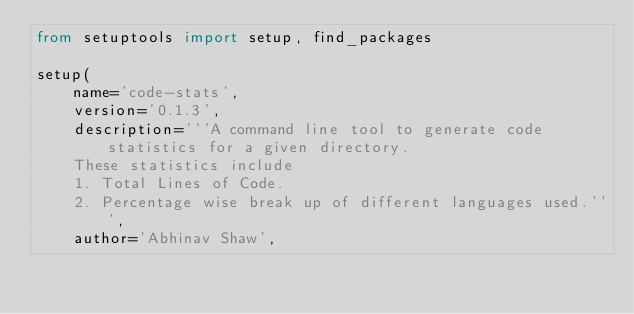Convert code to text. <code><loc_0><loc_0><loc_500><loc_500><_Python_>from setuptools import setup, find_packages

setup(
    name='code-stats',
    version='0.1.3',
    description='''A command line tool to generate code statistics for a given directory.
    These statistics include
    1. Total Lines of Code.
    2. Percentage wise break up of different languages used.''',
    author='Abhinav Shaw',</code> 